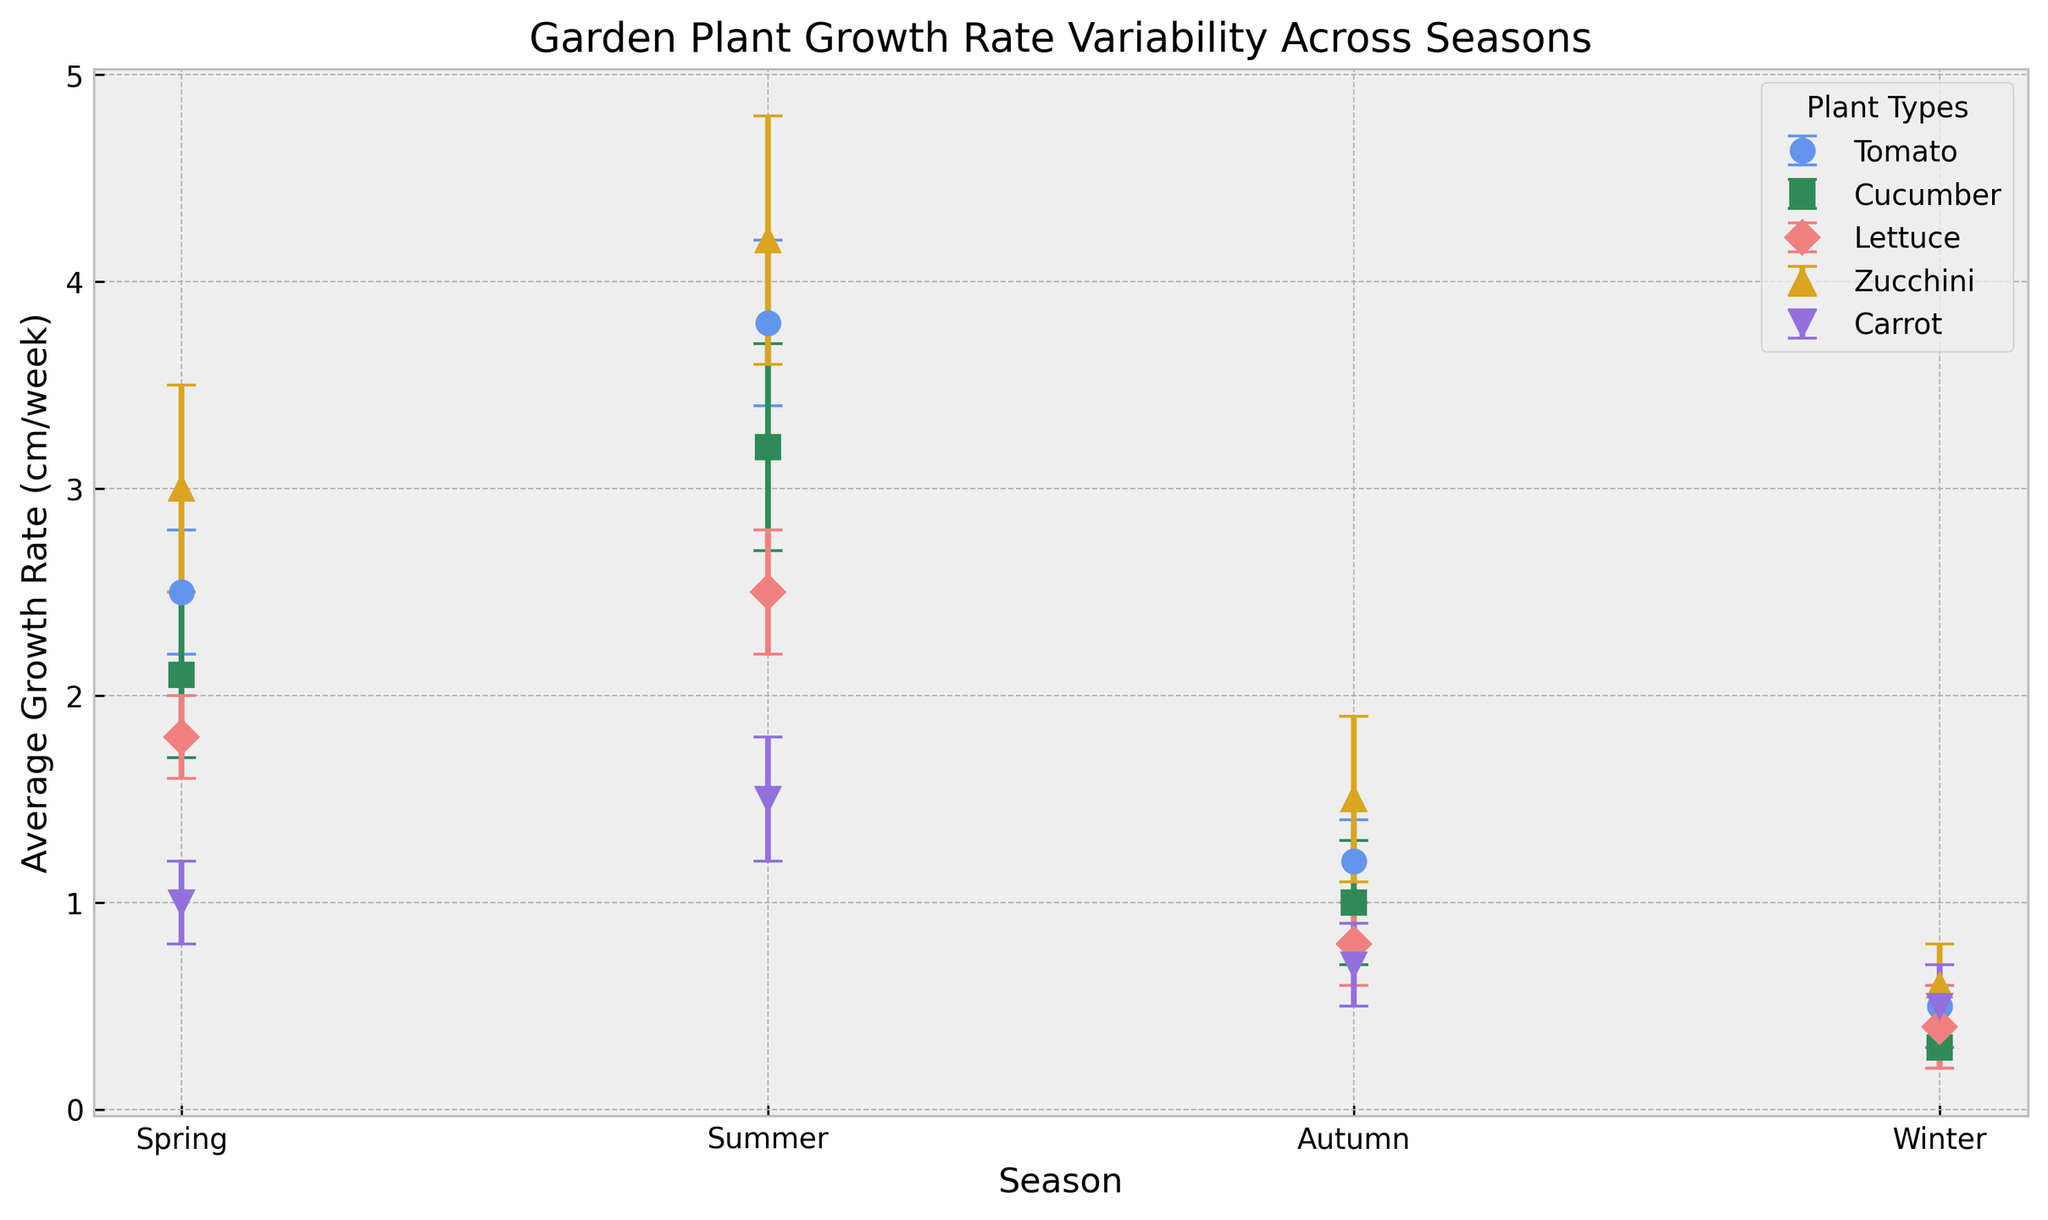What season does the Tomato plant have the highest average growth rate? Look for the peak value of the Tomato plant's growth rate across the seasons. The highest value corresponds to Summer, where it grows at 3.8 cm/week.
Answer: Summer Which plant has the smallest standard deviation in Spring? Examine the error bars in Spring to see which is the shortest. The Lettuce has the smallest standard deviation of 0.2 cm/week.
Answer: Lettuce Compare the average growth rate of Zucchini between Summer and Winter. How much greater is it in Summer? Identify the growth rates for Zucchini in Summer and Winter: 4.2 cm/week and 0.6 cm/week respectively. Compute the difference: 4.2 - 0.6 = 3.6 cm/week.
Answer: 3.6 cm/week Is there any plant that has an equal growth rate in Autumn and Winter? Compare the growth rates of each plant in both Autumn and Winter. Lettuce has the same growth rate of 0.4 cm/week in both.
Answer: Lettuce Which season shows the greatest variability in growth rates for all plants, as indicated by the error bars? Analyze the length of the error bars for each plant across all seasons. Summer shows the largest variability with larger error bars, especially for Zucchini (0.6 cm/week) and Cucumber (0.5 cm/week).
Answer: Summer In which season does the Carrot plant have its lowest growth rate? Look for the minimum value for Carrot's growth rate across the seasons. The lowest value is in Autumn, at 0.7 cm/week.
Answer: Autumn Consider the Tomato plant's growth rates across all seasons. Compute the average growth rate across these seasons. Sum the growth rates for the Tomato: 2.5 (Spring) + 3.8 (Summer) + 1.2 (Autumn) + 0.5 (Winter) = 8.0. Divide by the number of seasons: 8.0 / 4 = 2.0 cm/week.
Answer: 2.0 cm/week Which plant has the highest overall average growth rate across all seasons? Identify the plant with the highest average bar length across all seasons. Zucchini has the highest values, especially in Summer. Summing Zucchini’s growth rates: 3.0 (Spring) + 4.2 (Summer) + 1.5 (Autumn) + 0.6 (Winter) = 9.3 cm/week. Dividing by 4 results in 2.325 cm/week, which is the highest average.
Answer: Zucchini 